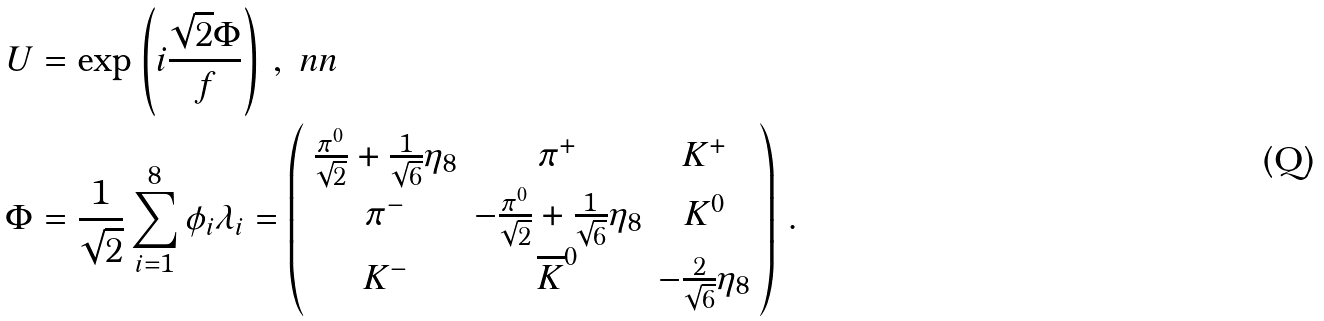<formula> <loc_0><loc_0><loc_500><loc_500>U & = \exp \left ( i \frac { \sqrt { 2 } \Phi } { f } \right ) \, , \ n n \\ \Phi & = \frac { 1 } { \sqrt { 2 } } \sum _ { i = 1 } ^ { 8 } \phi _ { i } \lambda _ { i } = \left ( \begin{array} { c c c } \frac { \pi ^ { 0 } } { \sqrt { 2 } } + \frac { 1 } { \sqrt { 6 } } \eta _ { 8 } & \pi ^ { + } & K ^ { + } \\ \pi ^ { - } & - \frac { \pi ^ { 0 } } { \sqrt { 2 } } + \frac { 1 } { \sqrt { 6 } } \eta _ { 8 } & K ^ { 0 } \\ K ^ { - } & \overline { K } ^ { 0 } & - \frac { 2 } { \sqrt { 6 } } \eta _ { 8 } \end{array} \right ) \, .</formula> 